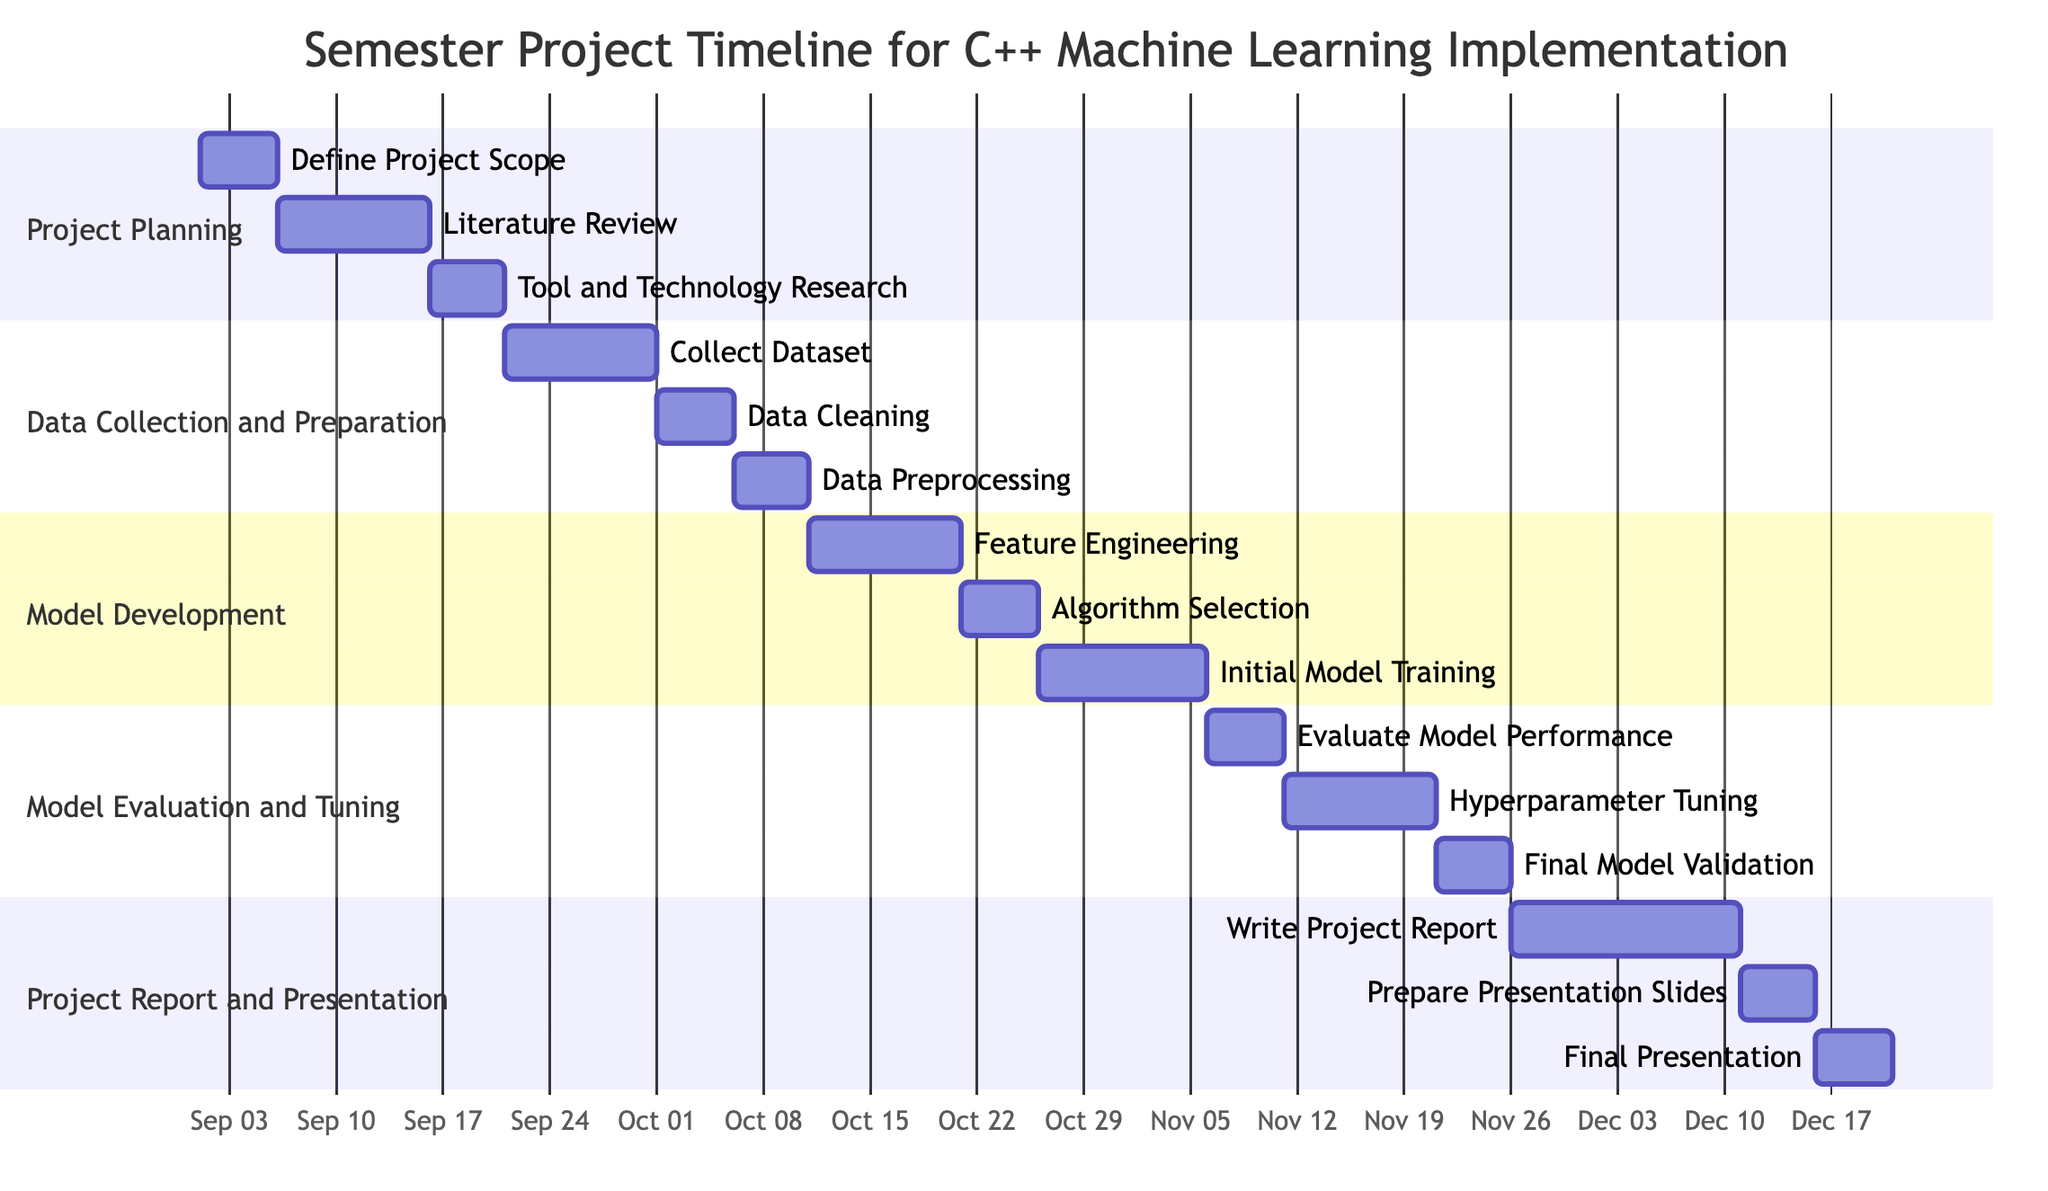What is the duration of the project planning phase? The project planning phase includes three milestones: "Define Project Scope" (5 days), "Literature Review" (10 days), and "Tool and Technology Research" (5 days). Adding these durations gives a total of 20 days for the project planning phase.
Answer: 20 days Which milestone ends last in the "Model Evaluation and Tuning" section? In the "Model Evaluation and Tuning" section, the milestones are "Evaluate Model Performance" (ends on November 10), "Hyperparameter Tuning" (ends on November 20), and "Final Model Validation" (ends on November 25). The last milestone to end is "Final Model Validation."
Answer: Final Model Validation How many tasks are in the "Project Report and Presentation" section? The "Project Report and Presentation" section consists of three milestones: "Write Project Report," "Prepare Presentation Slides," and "Final Presentation." Therefore, there are three tasks in this section.
Answer: 3 When does the "Data Preprocessing" task start? The "Data Preprocessing" milestone is after "Data Cleaning," which itself ends on October 5. Therefore, "Data Preprocessing" starts on October 6.
Answer: October 6 What is the total number of days allocated for the "Model Development" section? The milestones in "Model Development" are "Feature Engineering" (10 days), "Algorithm Selection" (5 days), and "Initial Model Training" (11 days). By adding these, the total duration is 10 + 5 + 11 = 26 days.
Answer: 26 days Which task immediately follows "Hyperparameter Tuning" in terms of task dependencies? "Hyperparameter Tuning" ends on November 20, and the next task that starts immediately after it is "Final Model Validation."
Answer: Final Model Validation What is the earliest start date for the "Data Collection and Preparation" task? The "Data Collection and Preparation" section begins with "Collect Dataset," which starts right after "Tool and Technology Research" ends on September 20. Thus, the earliest start date for this section is September 21.
Answer: September 21 What is the last milestone of the entire project timeline? The last milestone in the timeline is "Final Presentation," which ends on December 20. Therefore, it is the last milestone in the overall project timeline.
Answer: Final Presentation 